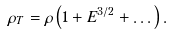<formula> <loc_0><loc_0><loc_500><loc_500>\rho _ { T } = \rho \left ( 1 + E ^ { 3 / 2 } + \dots \right ) .</formula> 